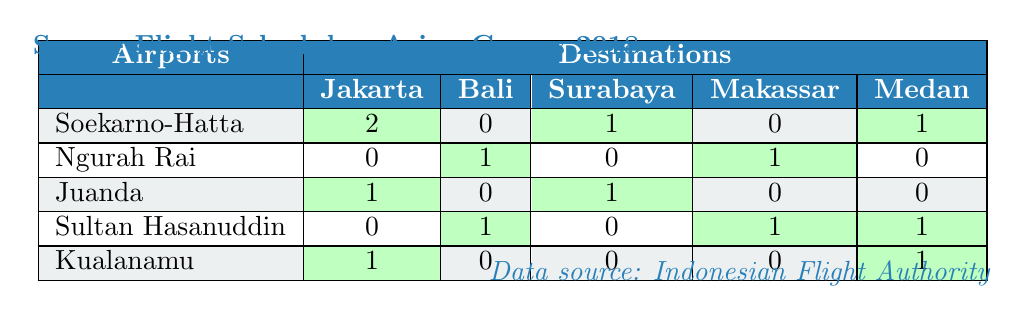What is the total number of flights from Soekarno-Hatta International Airport to Jakarta? The table shows that there are 2 flights from Soekarno-Hatta International Airport to Jakarta.
Answer: 2 How many flights are available from Sultan Hasanuddin International Airport to Bali? The table indicates that there is 1 flight from Sultan Hasanuddin International Airport to Bali.
Answer: 1 Does Juanda International Airport have any flights to Medan? The table shows that there are no flights from Juanda International Airport to Medan (0).
Answer: No Which airport has the highest number of flights to Surabaya? Checking the flights to Surabaya, Soekarno-Hatta and Juanda International Airports both have 1 flight listed, while the others have 0. Therefore, both Soekarno-Hatta and Juanda have the highest equal number of flights to Surabaya.
Answer: Soekarno-Hatta and Juanda What is the total number of flights from all airports to Makassar? By adding the flights from each airport to Makassar: Soekarno-Hatta (0) + Ngurah Rai (1) + Juanda (0) + Sultan Hasanuddin (1) + Kualanamu (0) = 2.
Answer: 2 Which airport has flights to the most destinations? By counting the number of non-zero flights for each airport: Soekarno-Hatta (3), Ngurah Rai (2), Juanda (2), Sultan Hasanuddin (3), Kualanamu (2). Soekarno-Hatta and Sultan Hasanuddin both have flights to the highest number of destinations, which is 3.
Answer: Soekarno-Hatta and Sultan Hasanuddin Are there flights from Kualanamu International Airport to both Jakarta and Medan? The table shows 1 flight to Jakarta and 1 flight to Medan from Kualanamu International Airport.
Answer: Yes What is the average number of flights to Jakarta from all airports? The number of flights to Jakarta is: Soekarno-Hatta (2), Ngurah Rai (0), Juanda (1), Sultan Hasanuddin (0), Kualanamu (1). The total is 2 + 0 + 1 + 0 + 1 = 4 from 5 airports, so the average is 4/5 = 0.8.
Answer: 0.8 How many airports have flights to both Bali and Medan? The airports with flights to Bali (Ngurah Rai, Sultan Hasanuddin) and Medan (Soekarno-Hatta, Sultan Hasanuddin, Kualanamu) are analyzed: Sultan Hasanuddin is the only airport that has flights to both destinations (1 and 1 respectively).
Answer: 1 Which airport has the least number of flights to any destination? Looking at the flight counts, Juanda International Airport has a flight count of 0 to Medan and Soekarno-Hatta has 0 to Makassar. However, Juanda does have the most zeros overall (0 to Bali and 0 to Medan), making it the airport with the least flights to any destination.
Answer: Juanda International Airport 